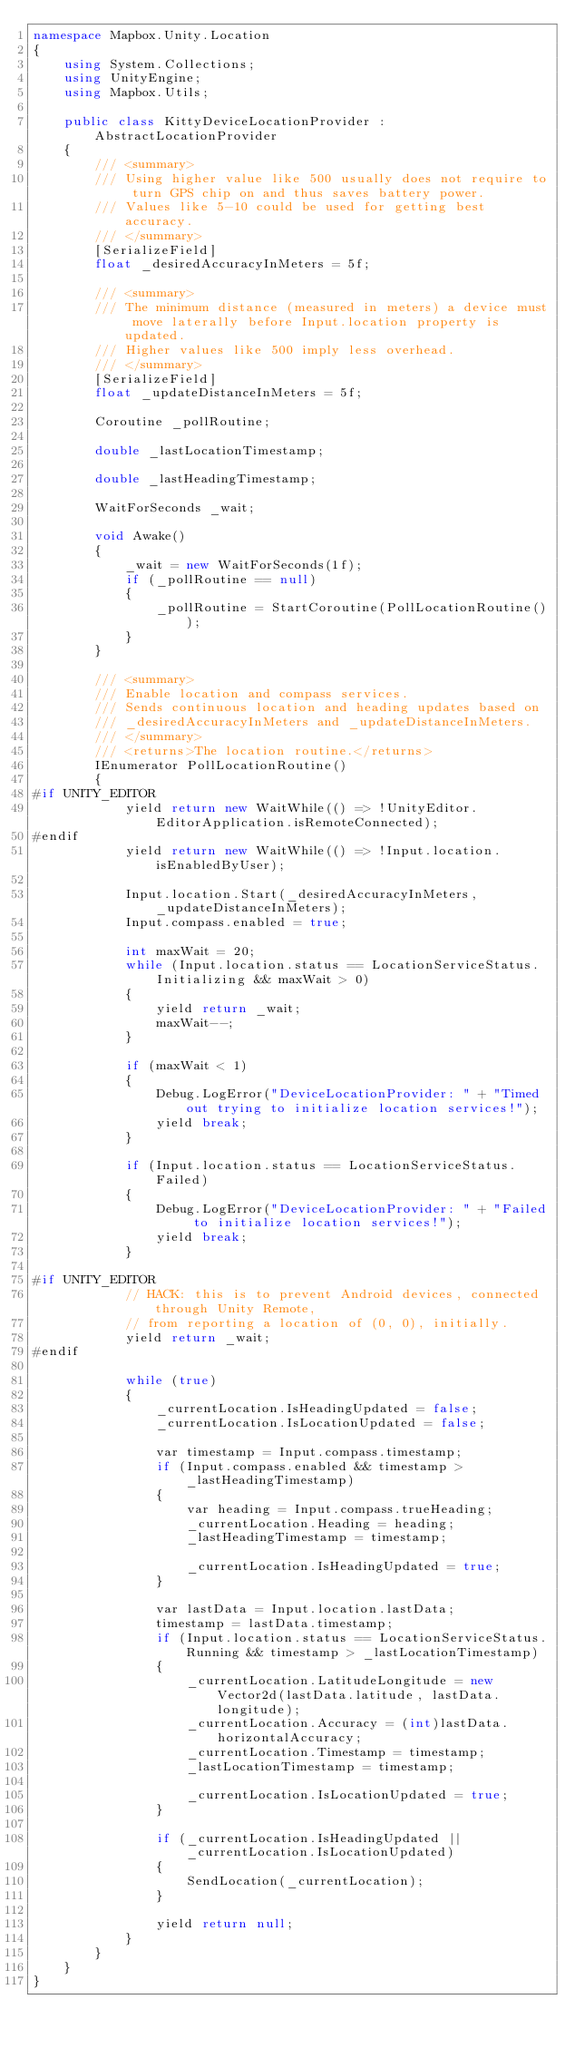Convert code to text. <code><loc_0><loc_0><loc_500><loc_500><_C#_>namespace Mapbox.Unity.Location
{
	using System.Collections;
	using UnityEngine;
	using Mapbox.Utils;
    
	public class KittyDeviceLocationProvider : AbstractLocationProvider
    {
		/// <summary>
		/// Using higher value like 500 usually does not require to turn GPS chip on and thus saves battery power. 
		/// Values like 5-10 could be used for getting best accuracy.
		/// </summary>
		[SerializeField]
		float _desiredAccuracyInMeters = 5f;

		/// <summary>
		/// The minimum distance (measured in meters) a device must move laterally before Input.location property is updated. 
		/// Higher values like 500 imply less overhead.
		/// </summary>
		[SerializeField]
		float _updateDistanceInMeters = 5f;

		Coroutine _pollRoutine;

		double _lastLocationTimestamp;

		double _lastHeadingTimestamp;

		WaitForSeconds _wait;

		void Awake()
		{
			_wait = new WaitForSeconds(1f);
			if (_pollRoutine == null)
			{
				_pollRoutine = StartCoroutine(PollLocationRoutine());
			}
		}

		/// <summary>
		/// Enable location and compass services.
		/// Sends continuous location and heading updates based on 
		/// _desiredAccuracyInMeters and _updateDistanceInMeters.
		/// </summary>
		/// <returns>The location routine.</returns>
		IEnumerator PollLocationRoutine()
		{
#if UNITY_EDITOR
			yield return new WaitWhile(() => !UnityEditor.EditorApplication.isRemoteConnected);
#endif
            yield return new WaitWhile(() => !Input.location.isEnabledByUser);
            
            Input.location.Start(_desiredAccuracyInMeters, _updateDistanceInMeters);
			Input.compass.enabled = true;

			int maxWait = 20;
			while (Input.location.status == LocationServiceStatus.Initializing && maxWait > 0)
			{
				yield return _wait;
				maxWait--;
			}

			if (maxWait < 1)
			{
				Debug.LogError("DeviceLocationProvider: " + "Timed out trying to initialize location services!");
				yield break;
			}

			if (Input.location.status == LocationServiceStatus.Failed)
			{
				Debug.LogError("DeviceLocationProvider: " + "Failed to initialize location services!");
				yield break;
			}

#if UNITY_EDITOR
			// HACK: this is to prevent Android devices, connected through Unity Remote, 
			// from reporting a location of (0, 0), initially.
			yield return _wait;
#endif
            
            while (true)
			{
				_currentLocation.IsHeadingUpdated = false;
				_currentLocation.IsLocationUpdated = false;

				var timestamp = Input.compass.timestamp;
				if (Input.compass.enabled && timestamp > _lastHeadingTimestamp)
				{
					var heading = Input.compass.trueHeading;
					_currentLocation.Heading = heading;
					_lastHeadingTimestamp = timestamp;

					_currentLocation.IsHeadingUpdated = true;
				}

				var lastData = Input.location.lastData;
				timestamp = lastData.timestamp;
				if (Input.location.status == LocationServiceStatus.Running && timestamp > _lastLocationTimestamp)
				{
					_currentLocation.LatitudeLongitude = new Vector2d(lastData.latitude, lastData.longitude);
					_currentLocation.Accuracy = (int)lastData.horizontalAccuracy;
					_currentLocation.Timestamp = timestamp;
					_lastLocationTimestamp = timestamp;

					_currentLocation.IsLocationUpdated = true;
				}

				if (_currentLocation.IsHeadingUpdated || _currentLocation.IsLocationUpdated)
				{
					SendLocation(_currentLocation);
				}

				yield return null;
			}
		}
	}
}</code> 